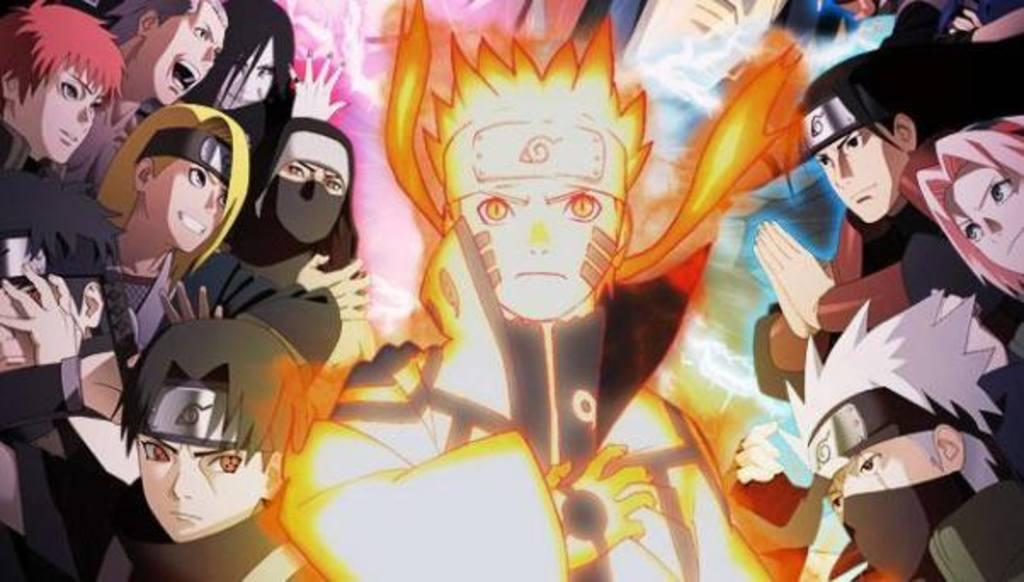What is the main subject of the image? There is a depiction of persons in the image. What type of orange can be seen hanging from the swing in the image? There is no orange or swing present in the image; it only depicts persons. 